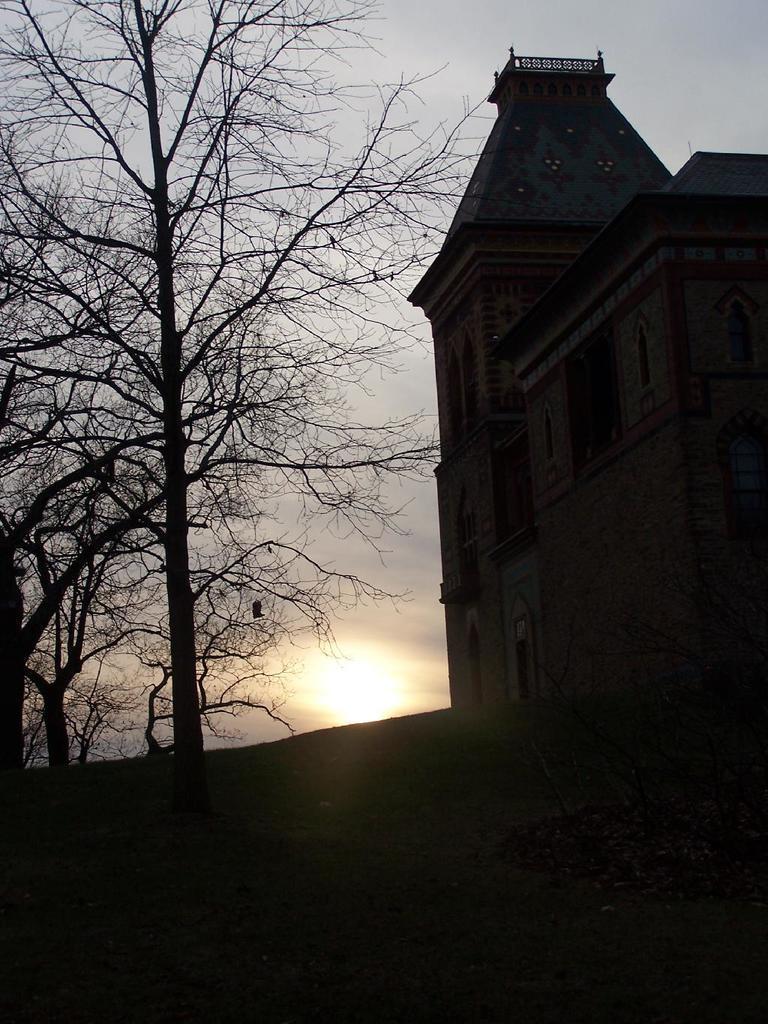Please provide a concise description of this image. In this image I can see a building and the ground. I can see few trees, the sky and the sun in the background. 